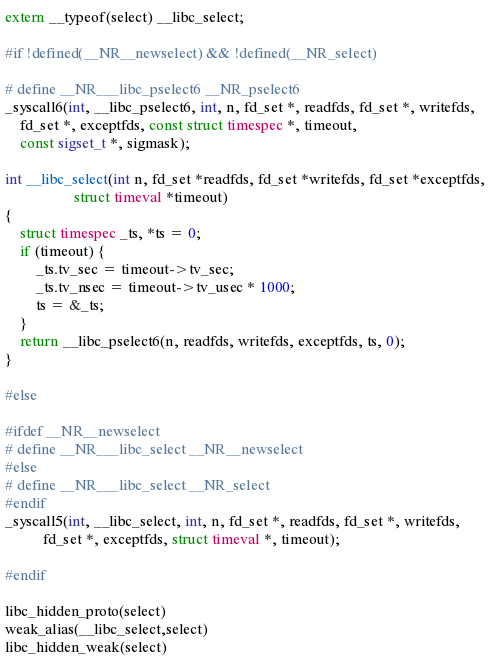<code> <loc_0><loc_0><loc_500><loc_500><_C_>extern __typeof(select) __libc_select;

#if !defined(__NR__newselect) && !defined(__NR_select)

# define __NR___libc_pselect6 __NR_pselect6
_syscall6(int, __libc_pselect6, int, n, fd_set *, readfds, fd_set *, writefds,
	fd_set *, exceptfds, const struct timespec *, timeout,
	const sigset_t *, sigmask);

int __libc_select(int n, fd_set *readfds, fd_set *writefds, fd_set *exceptfds,
                  struct timeval *timeout)
{
	struct timespec _ts, *ts = 0;
	if (timeout) {
		_ts.tv_sec = timeout->tv_sec;
		_ts.tv_nsec = timeout->tv_usec * 1000;
		ts = &_ts;
	}
	return __libc_pselect6(n, readfds, writefds, exceptfds, ts, 0);
}

#else

#ifdef __NR__newselect
# define __NR___libc_select __NR__newselect
#else
# define __NR___libc_select __NR_select
#endif
_syscall5(int, __libc_select, int, n, fd_set *, readfds, fd_set *, writefds,
		  fd_set *, exceptfds, struct timeval *, timeout);

#endif

libc_hidden_proto(select)
weak_alias(__libc_select,select)
libc_hidden_weak(select)
</code> 